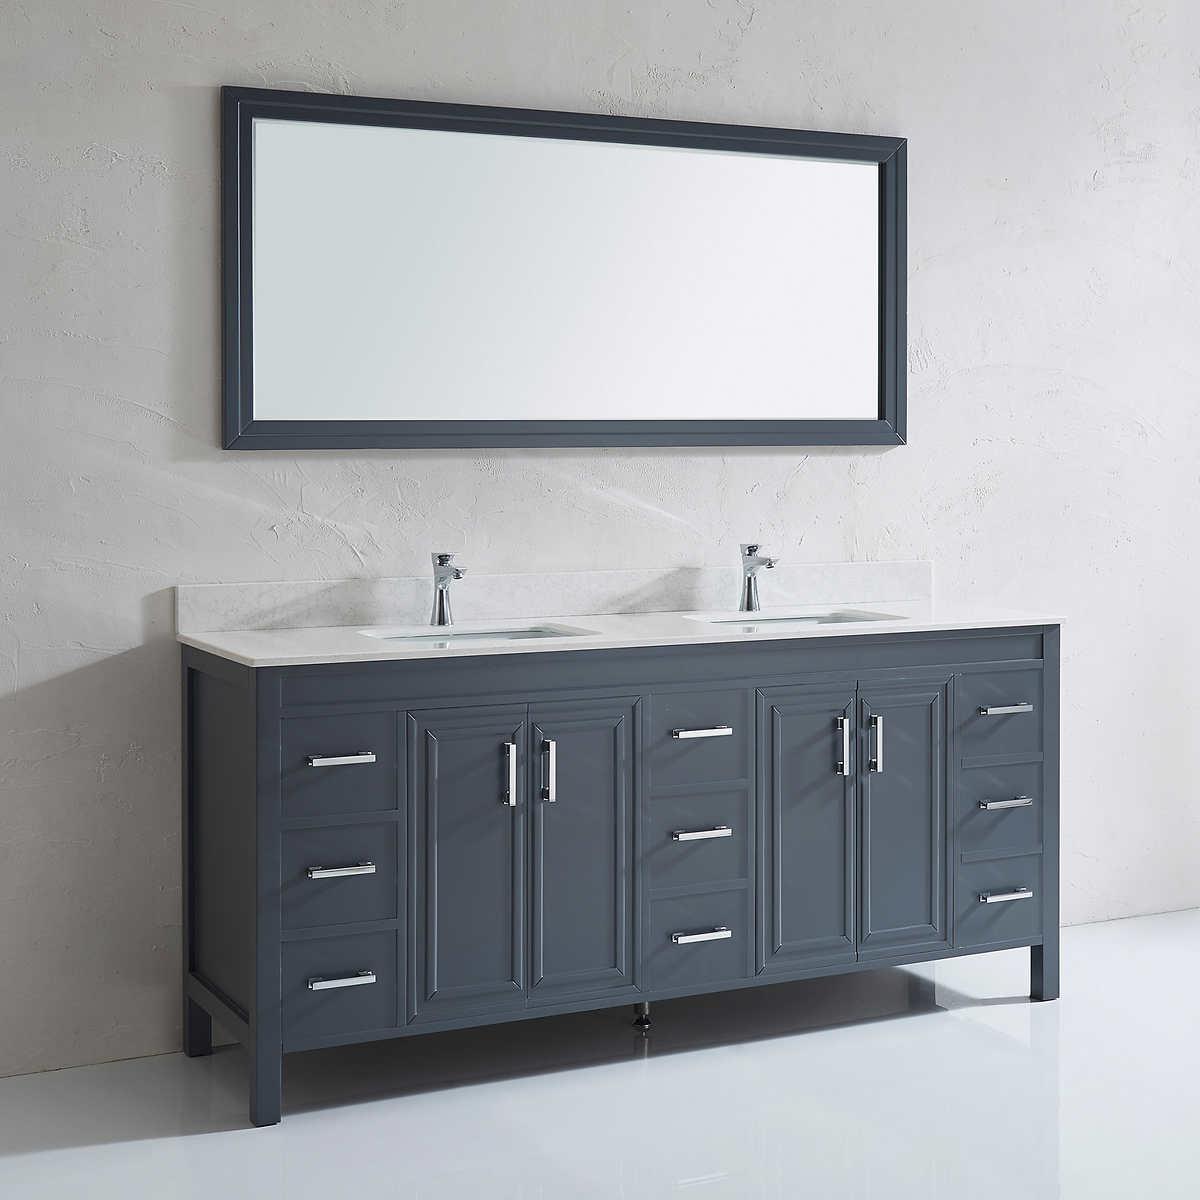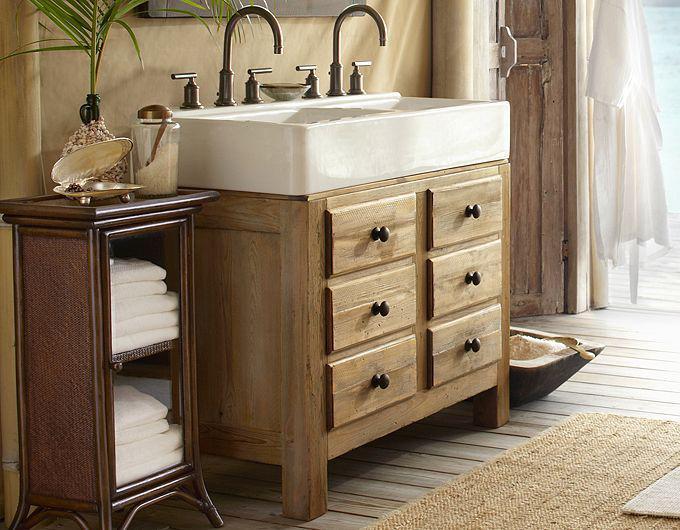The first image is the image on the left, the second image is the image on the right. Evaluate the accuracy of this statement regarding the images: "In one image, matching rectangular white sinks are placed on top of side-by-side vanities.". Is it true? Answer yes or no. No. The first image is the image on the left, the second image is the image on the right. Evaluate the accuracy of this statement regarding the images: "The right image shows a vanity with two gooseneck type faucets that curve downward.". Is it true? Answer yes or no. Yes. 